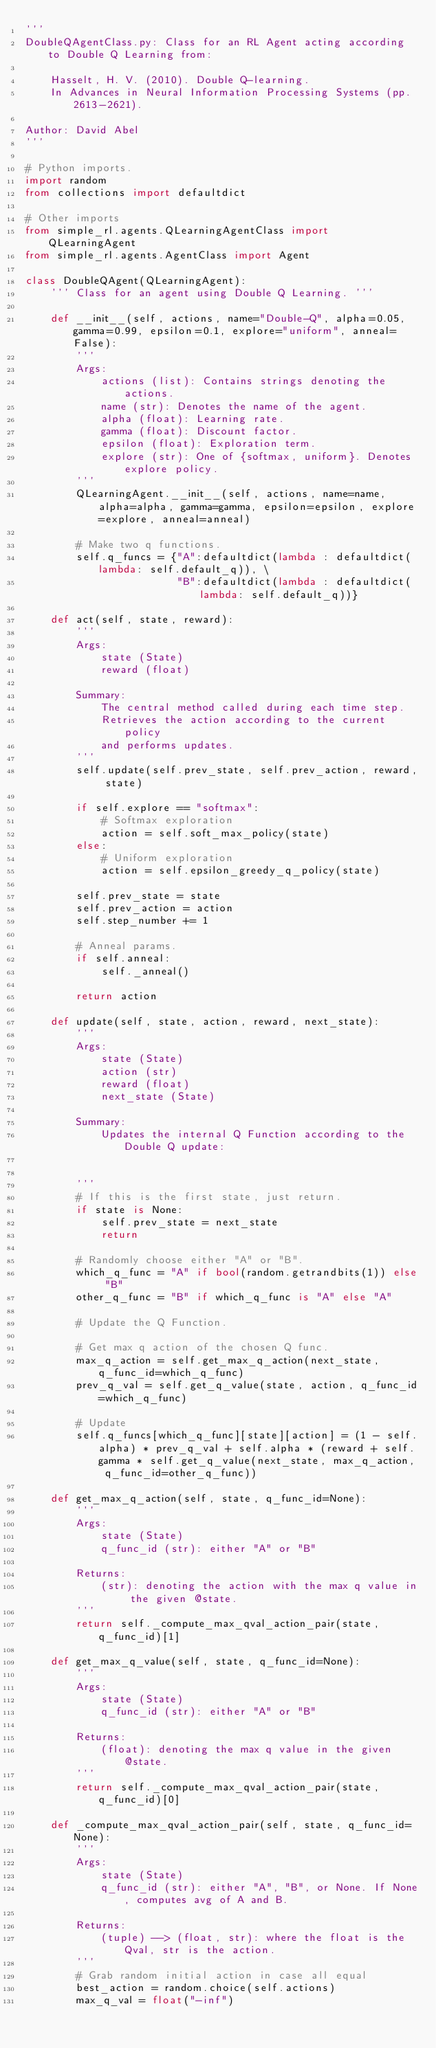Convert code to text. <code><loc_0><loc_0><loc_500><loc_500><_Python_>'''
DoubleQAgentClass.py: Class for an RL Agent acting according to Double Q Learning from:

    Hasselt, H. V. (2010). Double Q-learning.
    In Advances in Neural Information Processing Systems (pp. 2613-2621).

Author: David Abel
'''

# Python imports.
import random
from collections import defaultdict

# Other imports
from simple_rl.agents.QLearningAgentClass import QLearningAgent
from simple_rl.agents.AgentClass import Agent

class DoubleQAgent(QLearningAgent):
    ''' Class for an agent using Double Q Learning. '''

    def __init__(self, actions, name="Double-Q", alpha=0.05, gamma=0.99, epsilon=0.1, explore="uniform", anneal=False):
        '''
        Args:
            actions (list): Contains strings denoting the actions.
            name (str): Denotes the name of the agent.
            alpha (float): Learning rate.
            gamma (float): Discount factor.
            epsilon (float): Exploration term.
            explore (str): One of {softmax, uniform}. Denotes explore policy.
        '''
        QLearningAgent.__init__(self, actions, name=name, alpha=alpha, gamma=gamma, epsilon=epsilon, explore=explore, anneal=anneal)

        # Make two q functions.
        self.q_funcs = {"A":defaultdict(lambda : defaultdict(lambda: self.default_q)), \
                        "B":defaultdict(lambda : defaultdict(lambda: self.default_q))}

    def act(self, state, reward):
        '''
        Args:
            state (State)
            reward (float)

        Summary:
            The central method called during each time step.
            Retrieves the action according to the current policy
            and performs updates.
        '''
        self.update(self.prev_state, self.prev_action, reward, state)
        
        if self.explore == "softmax":
            # Softmax exploration
            action = self.soft_max_policy(state)
        else:
            # Uniform exploration
            action = self.epsilon_greedy_q_policy(state)

        self.prev_state = state
        self.prev_action = action
        self.step_number += 1

        # Anneal params.
        if self.anneal:
            self._anneal()

        return action

    def update(self, state, action, reward, next_state):
        '''
        Args:
            state (State)
            action (str)
            reward (float)
            next_state (State)

        Summary:
            Updates the internal Q Function according to the Double Q update:


        '''
        # If this is the first state, just return.
        if state is None:
            self.prev_state = next_state
            return

        # Randomly choose either "A" or "B".
        which_q_func = "A" if bool(random.getrandbits(1)) else "B"
        other_q_func = "B" if which_q_func is "A" else "A"

        # Update the Q Function.

        # Get max q action of the chosen Q func.
        max_q_action = self.get_max_q_action(next_state, q_func_id=which_q_func)
        prev_q_val = self.get_q_value(state, action, q_func_id=which_q_func)

        # Update
        self.q_funcs[which_q_func][state][action] = (1 - self.alpha) * prev_q_val + self.alpha * (reward + self.gamma * self.get_q_value(next_state, max_q_action, q_func_id=other_q_func))

    def get_max_q_action(self, state, q_func_id=None):
        '''
        Args:
            state (State)
            q_func_id (str): either "A" or "B"

        Returns:
            (str): denoting the action with the max q value in the given @state.
        '''
        return self._compute_max_qval_action_pair(state, q_func_id)[1]

    def get_max_q_value(self, state, q_func_id=None):
        '''
        Args:
            state (State)
            q_func_id (str): either "A" or "B"

        Returns:
            (float): denoting the max q value in the given @state.
        '''
        return self._compute_max_qval_action_pair(state, q_func_id)[0]
    
    def _compute_max_qval_action_pair(self, state, q_func_id=None):
        '''
        Args:
            state (State)
            q_func_id (str): either "A", "B", or None. If None, computes avg of A and B.

        Returns:
            (tuple) --> (float, str): where the float is the Qval, str is the action.
        '''
        # Grab random initial action in case all equal
        best_action = random.choice(self.actions)
        max_q_val = float("-inf")</code> 